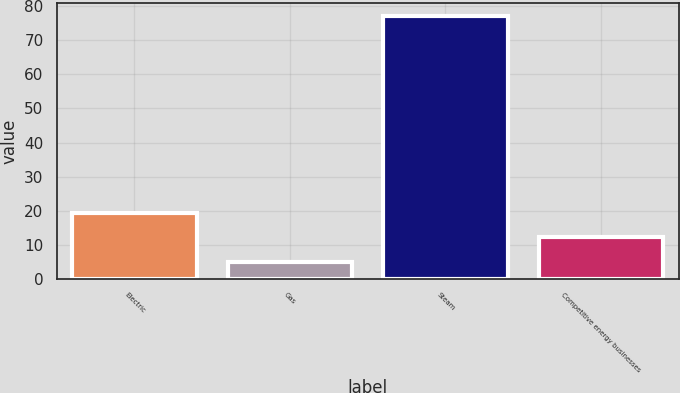<chart> <loc_0><loc_0><loc_500><loc_500><bar_chart><fcel>Electric<fcel>Gas<fcel>Steam<fcel>Competitive energy businesses<nl><fcel>19.4<fcel>5<fcel>77<fcel>12.2<nl></chart> 